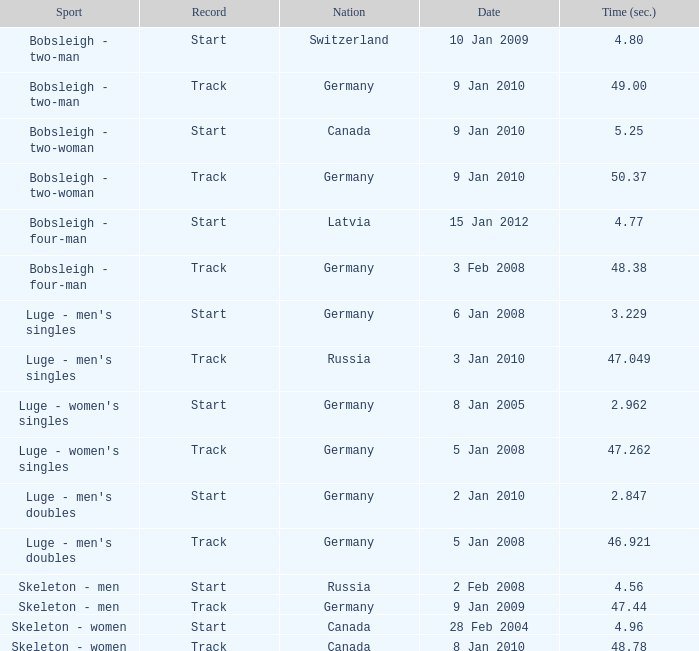Which nation had a time of 48.38? Germany. 